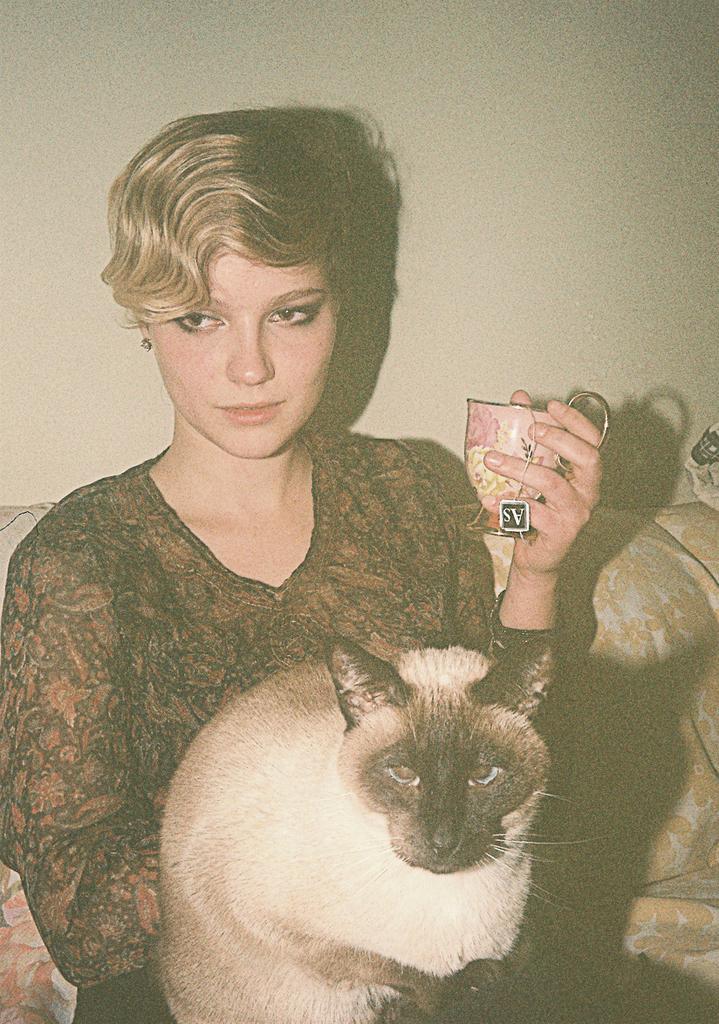In one or two sentences, can you explain what this image depicts? This picture describes about a woman, she holds a cat and a cup in her hands and she seated in the sofa. 